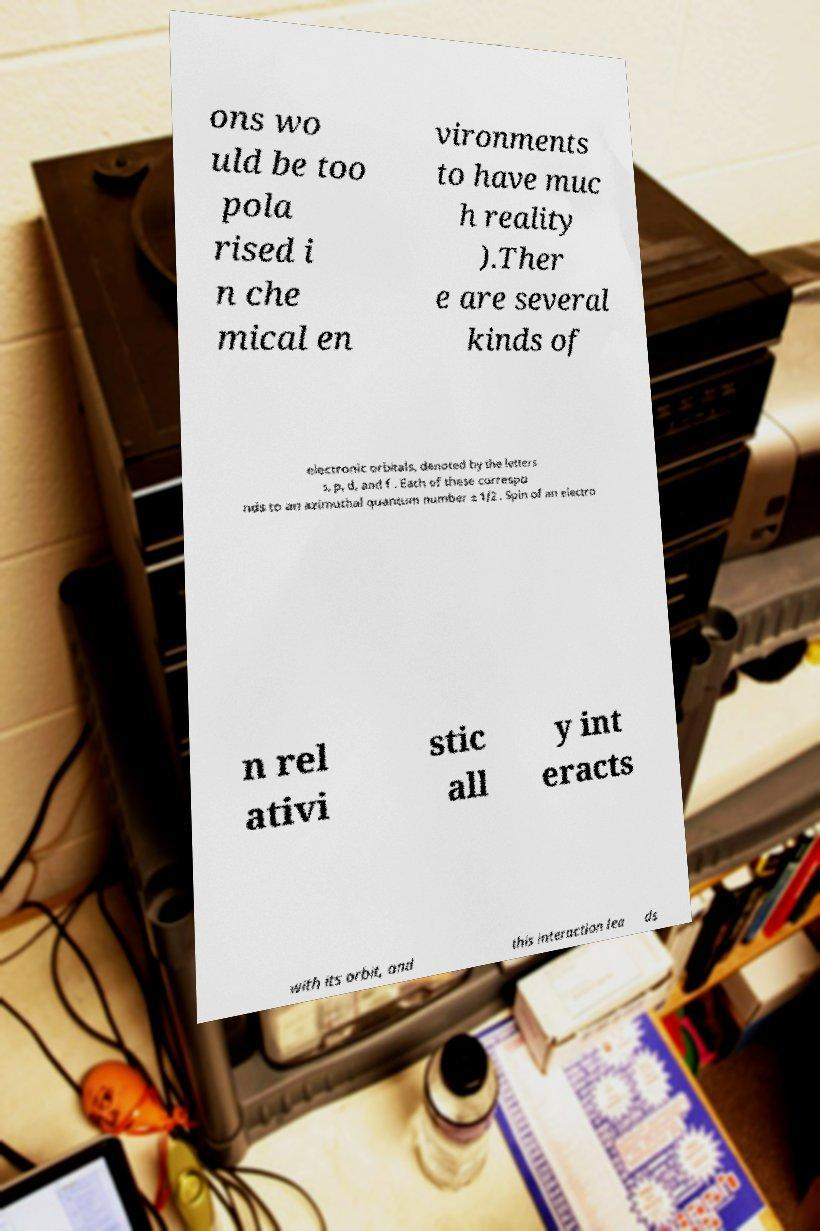Can you accurately transcribe the text from the provided image for me? ons wo uld be too pola rised i n che mical en vironments to have muc h reality ).Ther e are several kinds of electronic orbitals, denoted by the letters s, p, d, and f . Each of these correspo nds to an azimuthal quantum number ± 1/2 . Spin of an electro n rel ativi stic all y int eracts with its orbit, and this interaction lea ds 